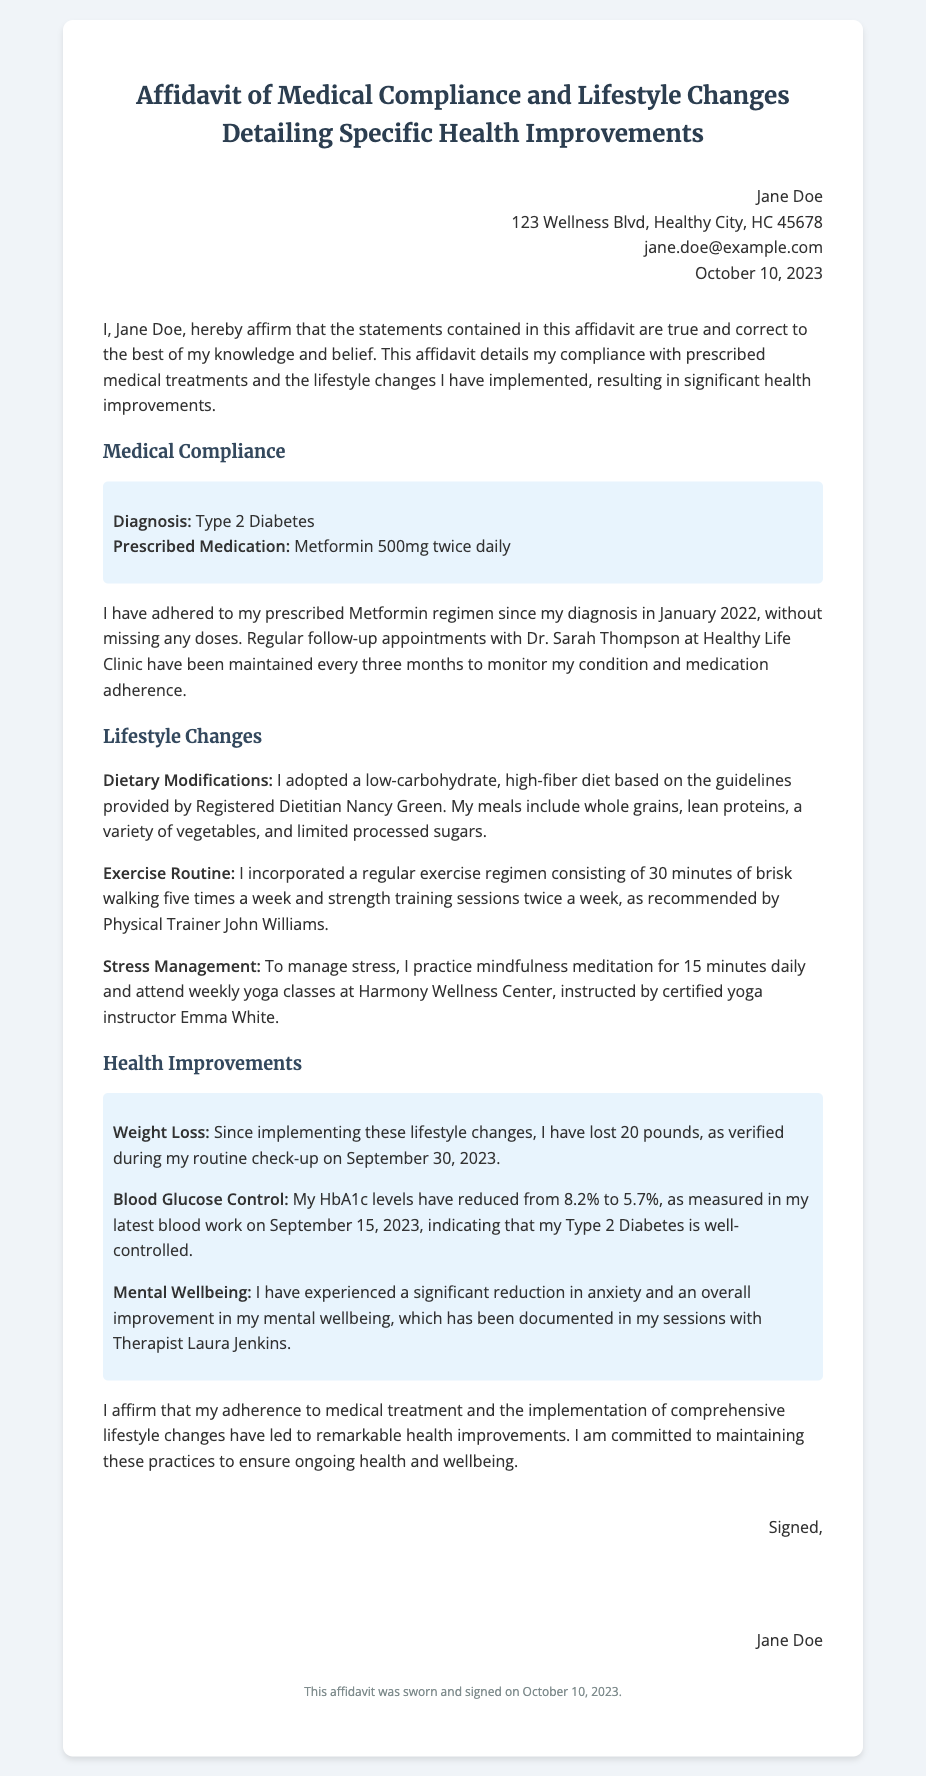What is the name of the individual signing the affidavit? The name of the individual is mentioned at the beginning of the document, signed by Jane Doe.
Answer: Jane Doe What is the diagnosis stated in the affidavit? The diagnosis indicated in the affidavit is specified under the Medical Compliance section.
Answer: Type 2 Diabetes What medication is prescribed to the individual? The prescribed medication is listed as part of the medical information provided in the affidavit.
Answer: Metformin 500mg How much weight has the individual lost? The weight loss is mentioned under the Health Improvements section, specifically stating the amount lost.
Answer: 20 pounds What is the date of the last blood work mentioned? The date of the last blood work is specified in the Health Improvements section regarding the HbA1c levels.
Answer: September 15, 2023 Who provided nutritional guidance? The entity or person providing dietary guidelines is identified in the lifestyle changes section.
Answer: Registered Dietitian Nancy Green How often does the individual attend follow-up appointments? The frequency of the follow-up appointments is noted in the medical compliance section of the affidavit.
Answer: Every three months What is the individual's current HbA1c level? The current HbA1c level is provided in the Health Improvements section to highlight blood glucose control.
Answer: 5.7% What type of routine has the individual incorporated for exercise? The specific type of exercise routine adapted by the individual is outlined under the Lifestyle Changes section.
Answer: Brisk walking and strength training 